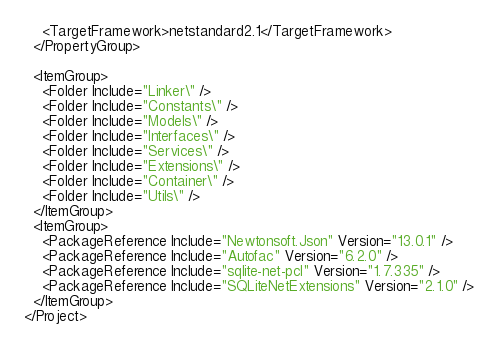<code> <loc_0><loc_0><loc_500><loc_500><_XML_>    <TargetFramework>netstandard2.1</TargetFramework>
  </PropertyGroup>

  <ItemGroup>
    <Folder Include="Linker\" />
    <Folder Include="Constants\" />
    <Folder Include="Models\" />
    <Folder Include="Interfaces\" />
    <Folder Include="Services\" />
    <Folder Include="Extensions\" />
    <Folder Include="Container\" />
    <Folder Include="Utils\" />
  </ItemGroup>
  <ItemGroup>
    <PackageReference Include="Newtonsoft.Json" Version="13.0.1" />
    <PackageReference Include="Autofac" Version="6.2.0" />
    <PackageReference Include="sqlite-net-pcl" Version="1.7.335" />
    <PackageReference Include="SQLiteNetExtensions" Version="2.1.0" />
  </ItemGroup>
</Project>
</code> 